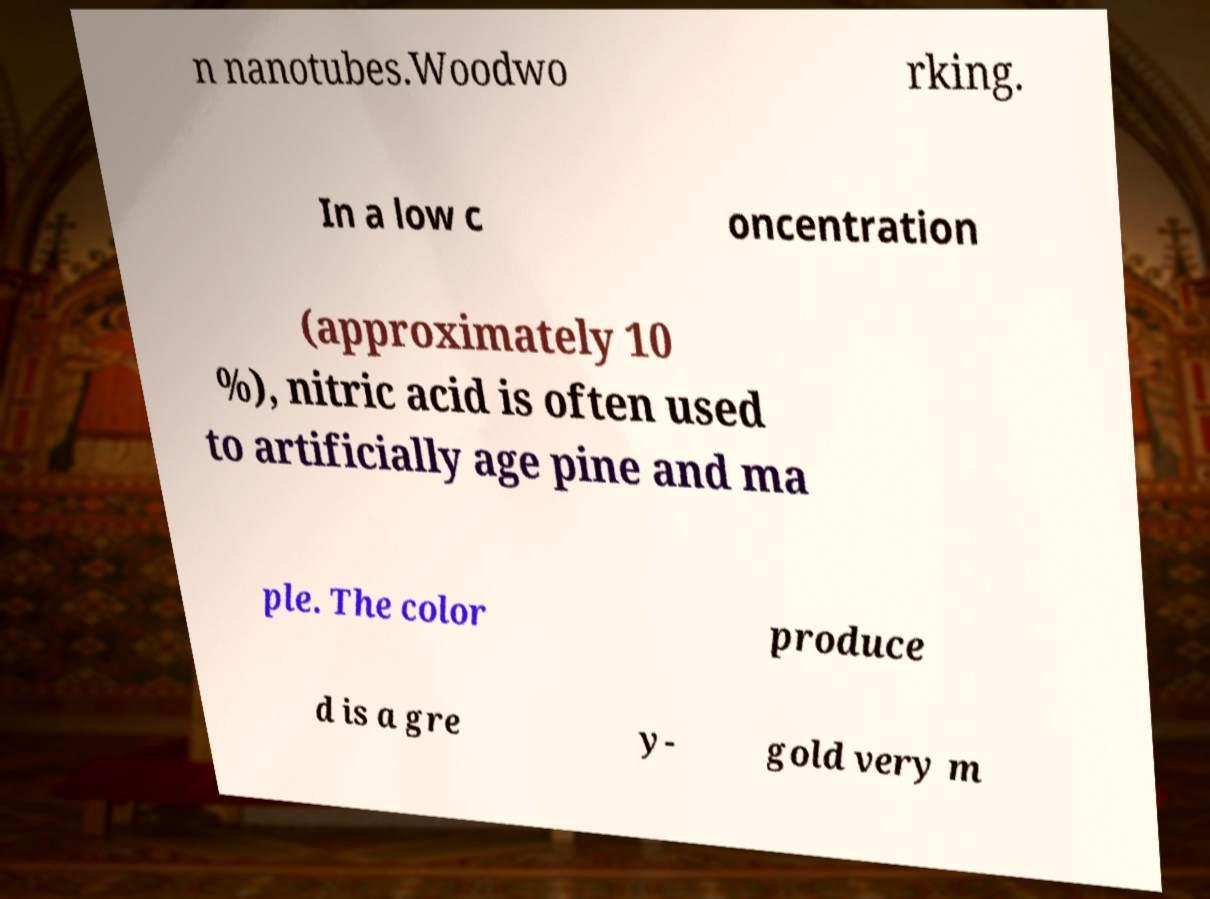For documentation purposes, I need the text within this image transcribed. Could you provide that? n nanotubes.Woodwo rking. In a low c oncentration (approximately 10 %), nitric acid is often used to artificially age pine and ma ple. The color produce d is a gre y- gold very m 